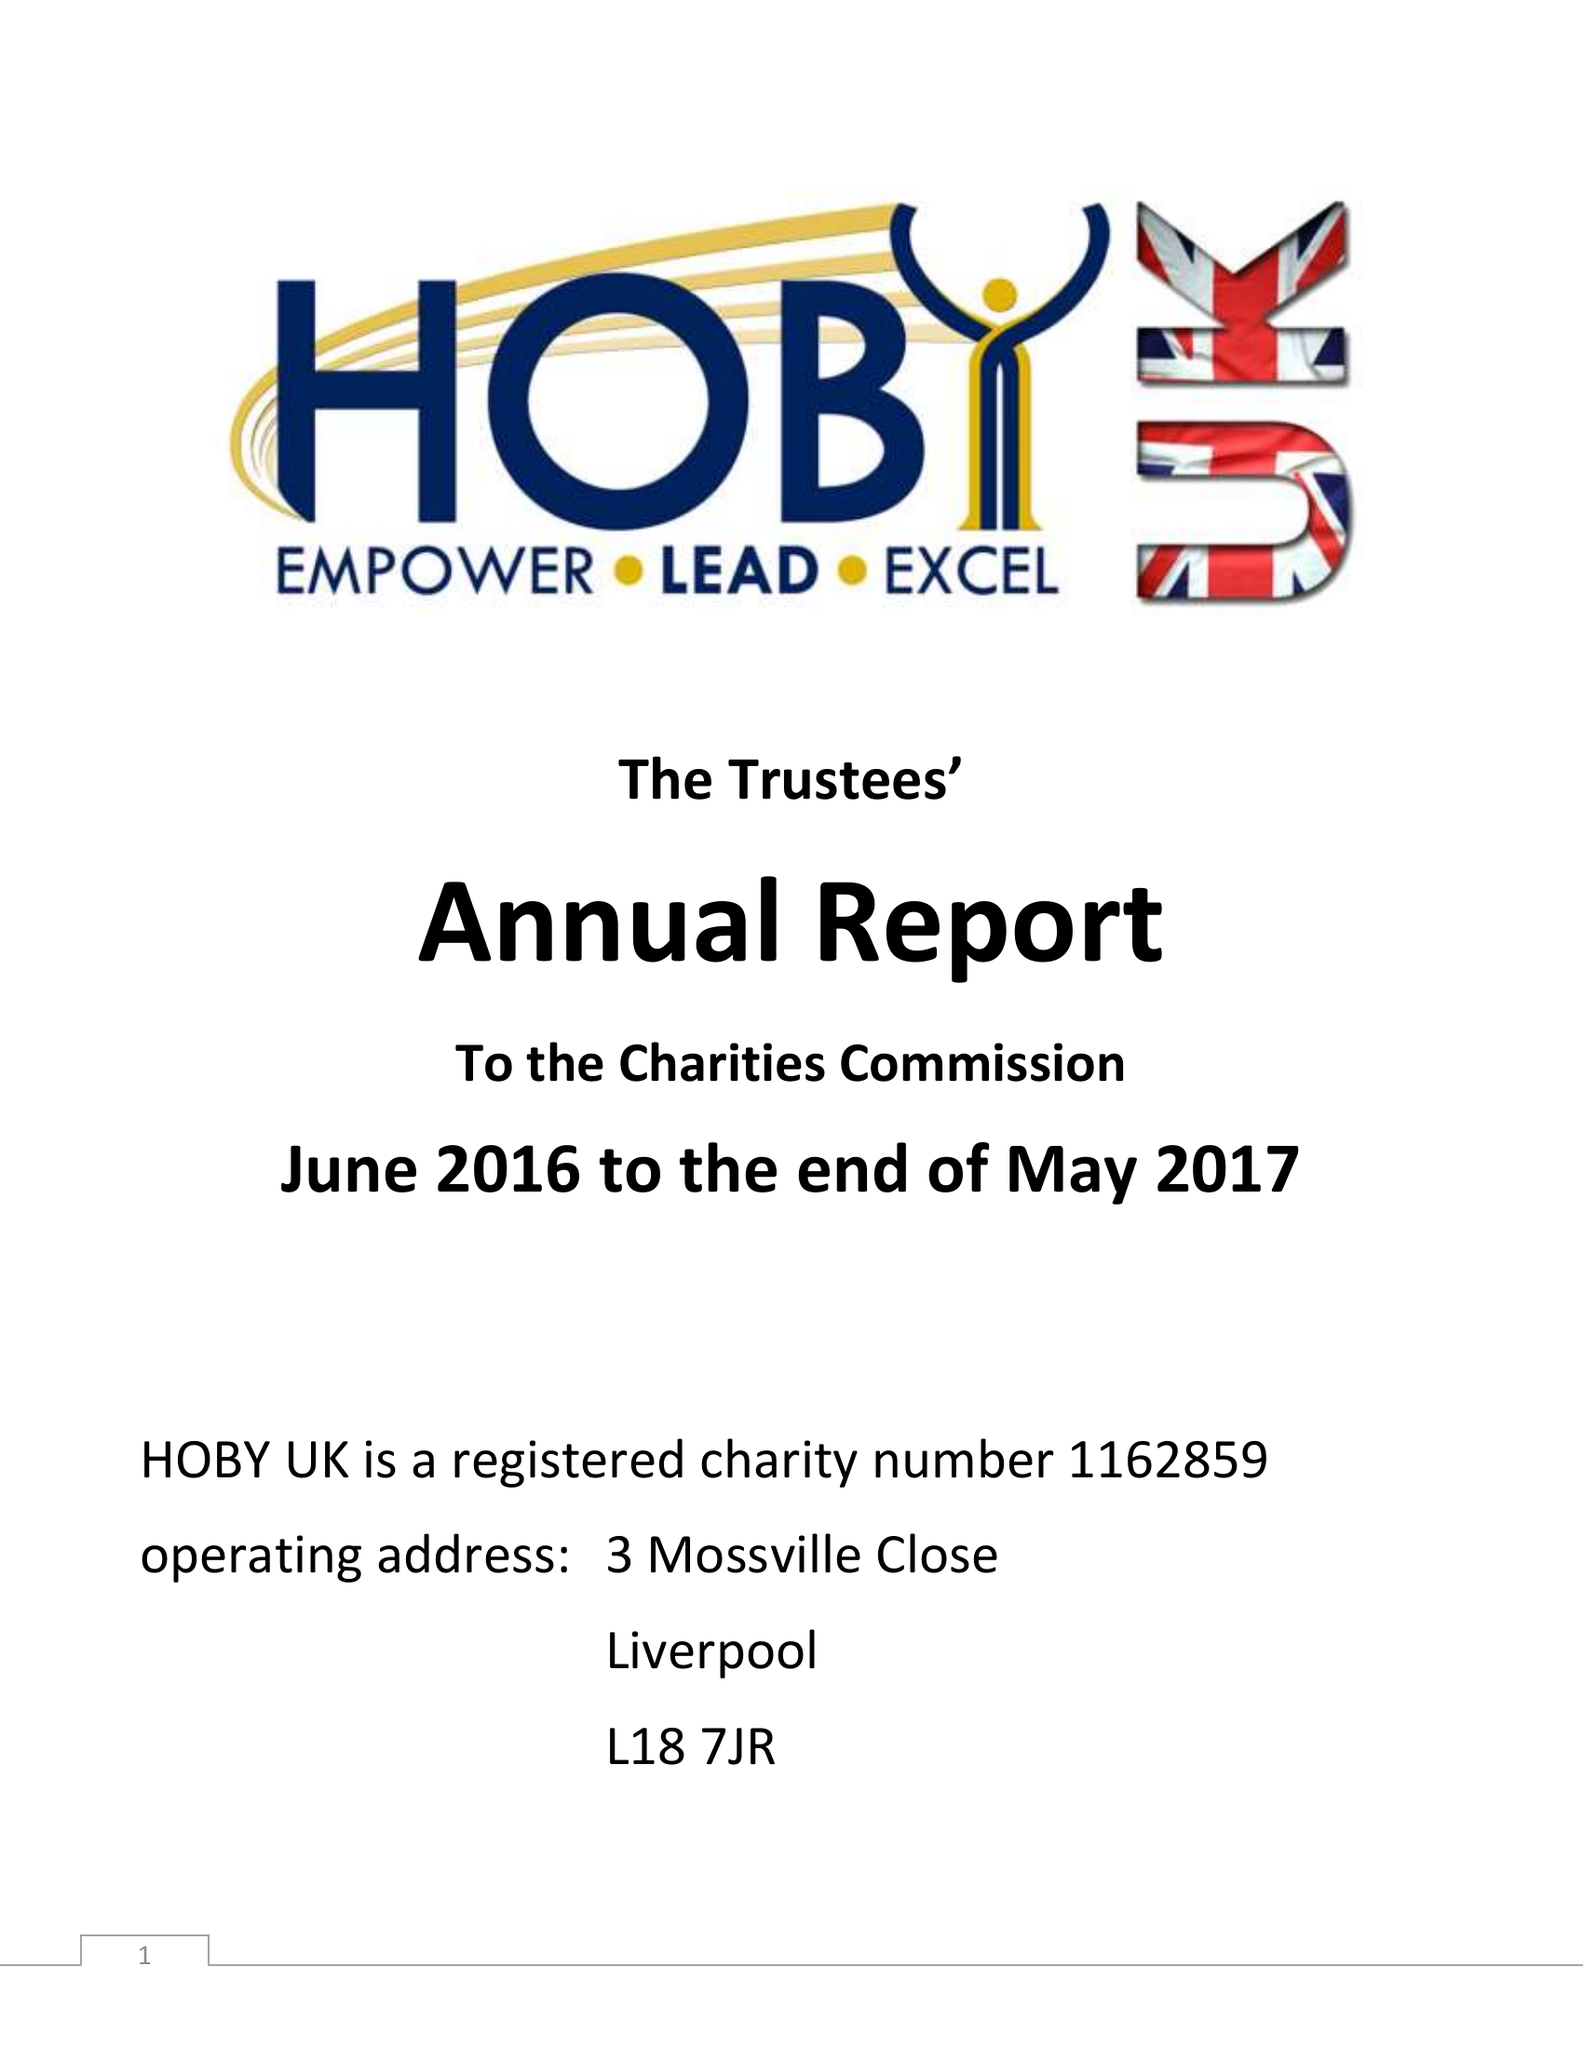What is the value for the charity_number?
Answer the question using a single word or phrase. 1162859 